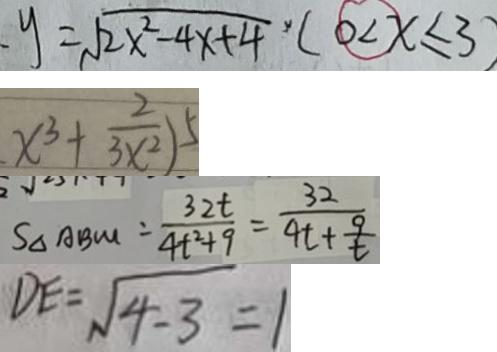Convert formula to latex. <formula><loc_0><loc_0><loc_500><loc_500>、 y = \sqrt { 2 x ^ { 2 } - 4 x + 4 } \times ( 0 < x \leq 3 ) 
 x ^ { 3 } + \frac { 2 } { 3 x ^ { 2 } } ) ^ { 5 } 
 S _ { \Delta A B M } = \frac { 3 2 t } { 4 t ^ { 2 } + 9 } = \frac { 3 2 } { 4 t + \frac { 9 } { t } } 
 D E = \sqrt { 4 - 3 } = 1</formula> 